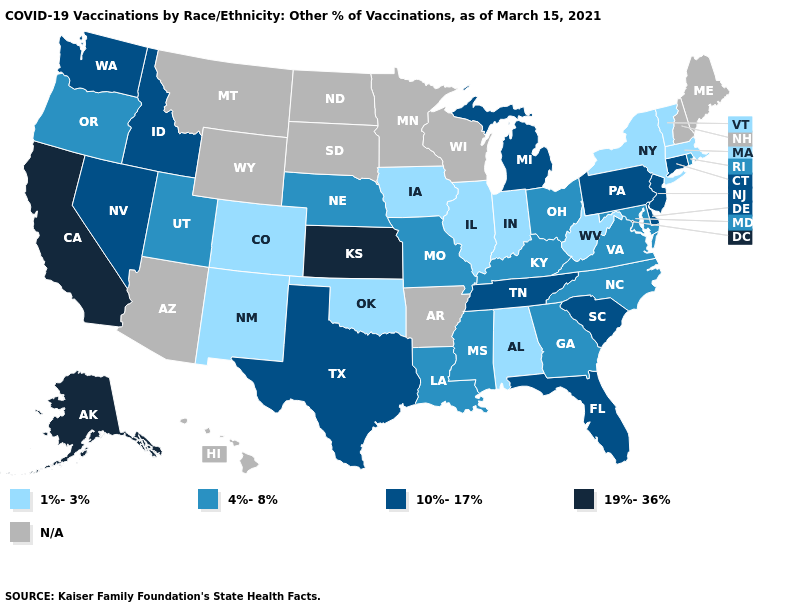Name the states that have a value in the range N/A?
Concise answer only. Arizona, Arkansas, Hawaii, Maine, Minnesota, Montana, New Hampshire, North Dakota, South Dakota, Wisconsin, Wyoming. What is the value of Utah?
Give a very brief answer. 4%-8%. Does Alaska have the highest value in the West?
Quick response, please. Yes. Does Colorado have the lowest value in the USA?
Answer briefly. Yes. Does the first symbol in the legend represent the smallest category?
Answer briefly. Yes. How many symbols are there in the legend?
Keep it brief. 5. Name the states that have a value in the range 19%-36%?
Short answer required. Alaska, California, Kansas. What is the value of Hawaii?
Short answer required. N/A. Name the states that have a value in the range 1%-3%?
Short answer required. Alabama, Colorado, Illinois, Indiana, Iowa, Massachusetts, New Mexico, New York, Oklahoma, Vermont, West Virginia. Among the states that border Delaware , does Maryland have the highest value?
Short answer required. No. Which states have the lowest value in the MidWest?
Concise answer only. Illinois, Indiana, Iowa. Does the first symbol in the legend represent the smallest category?
Concise answer only. Yes. Among the states that border California , does Nevada have the highest value?
Concise answer only. Yes. What is the highest value in states that border Michigan?
Give a very brief answer. 4%-8%. 